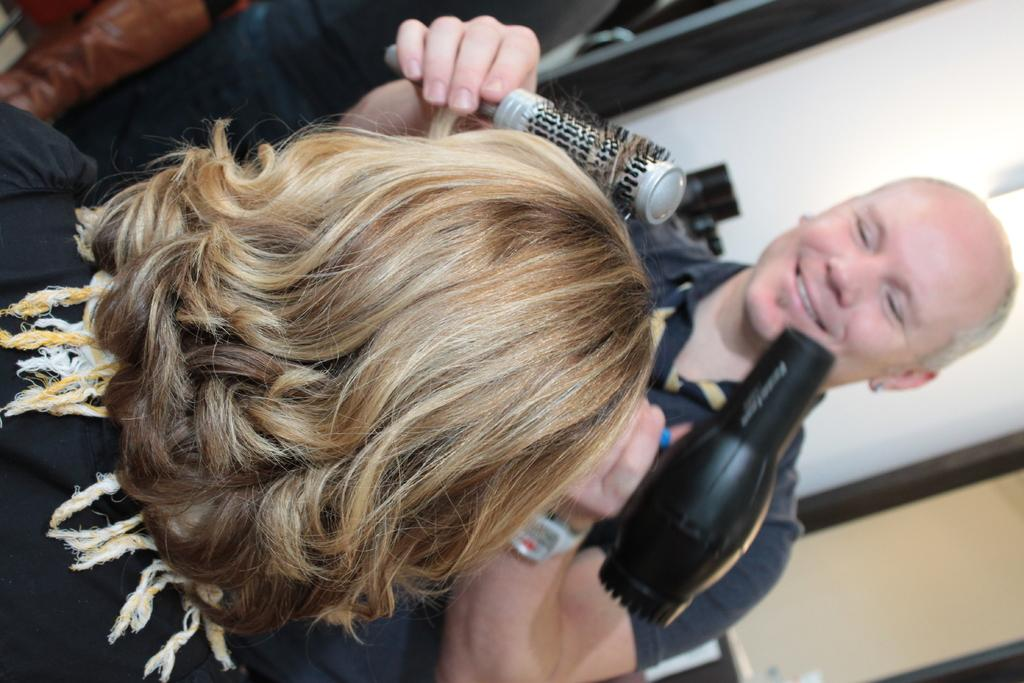What is the man in the image holding? The man is holding a brush and a hair dryer. Can you describe the woman's position in the image? The woman is on the left side of the image. What might the man be doing with the brush and hair dryer? The man might be styling someone's hair with the brush and hair dryer. What type of noise can be heard coming from the yam in the image? There is no yam present in the image, so it is not possible to determine what type of noise might be coming from it. 